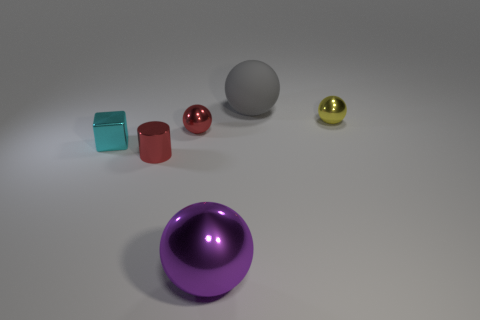There is a shiny object that is the same color as the cylinder; what size is it?
Offer a terse response. Small. Are there any other things that are the same material as the large gray sphere?
Your answer should be compact. No. What number of other objects are there of the same color as the shiny cylinder?
Your response must be concise. 1. Do the shiny cylinder and the small ball on the left side of the small yellow ball have the same color?
Offer a terse response. Yes. There is a metal ball on the right side of the large gray object; what is its size?
Keep it short and to the point. Small. How many metal things are to the right of the small object that is on the right side of the thing that is behind the small yellow ball?
Your response must be concise. 0. What number of green objects are either small objects or big shiny things?
Your response must be concise. 0. What color is the big thing that is the same material as the red cylinder?
Provide a short and direct response. Purple. How many large things are either yellow things or balls?
Provide a succinct answer. 2. Are there fewer red shiny objects than gray objects?
Provide a succinct answer. No. 